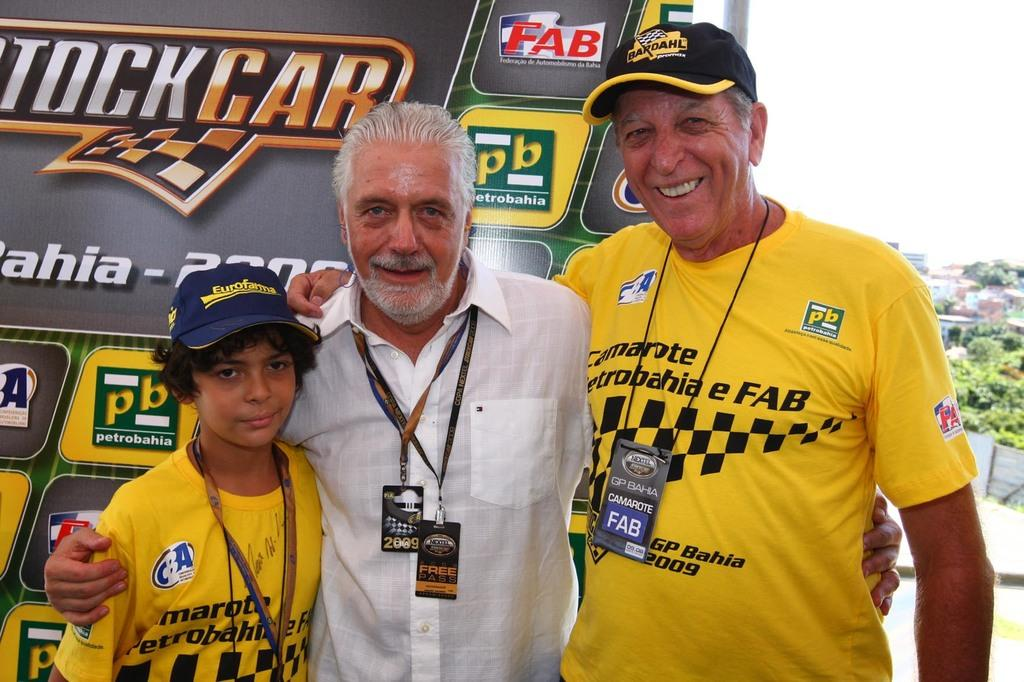<image>
Create a compact narrative representing the image presented. a few people with a stock car ad behind them 